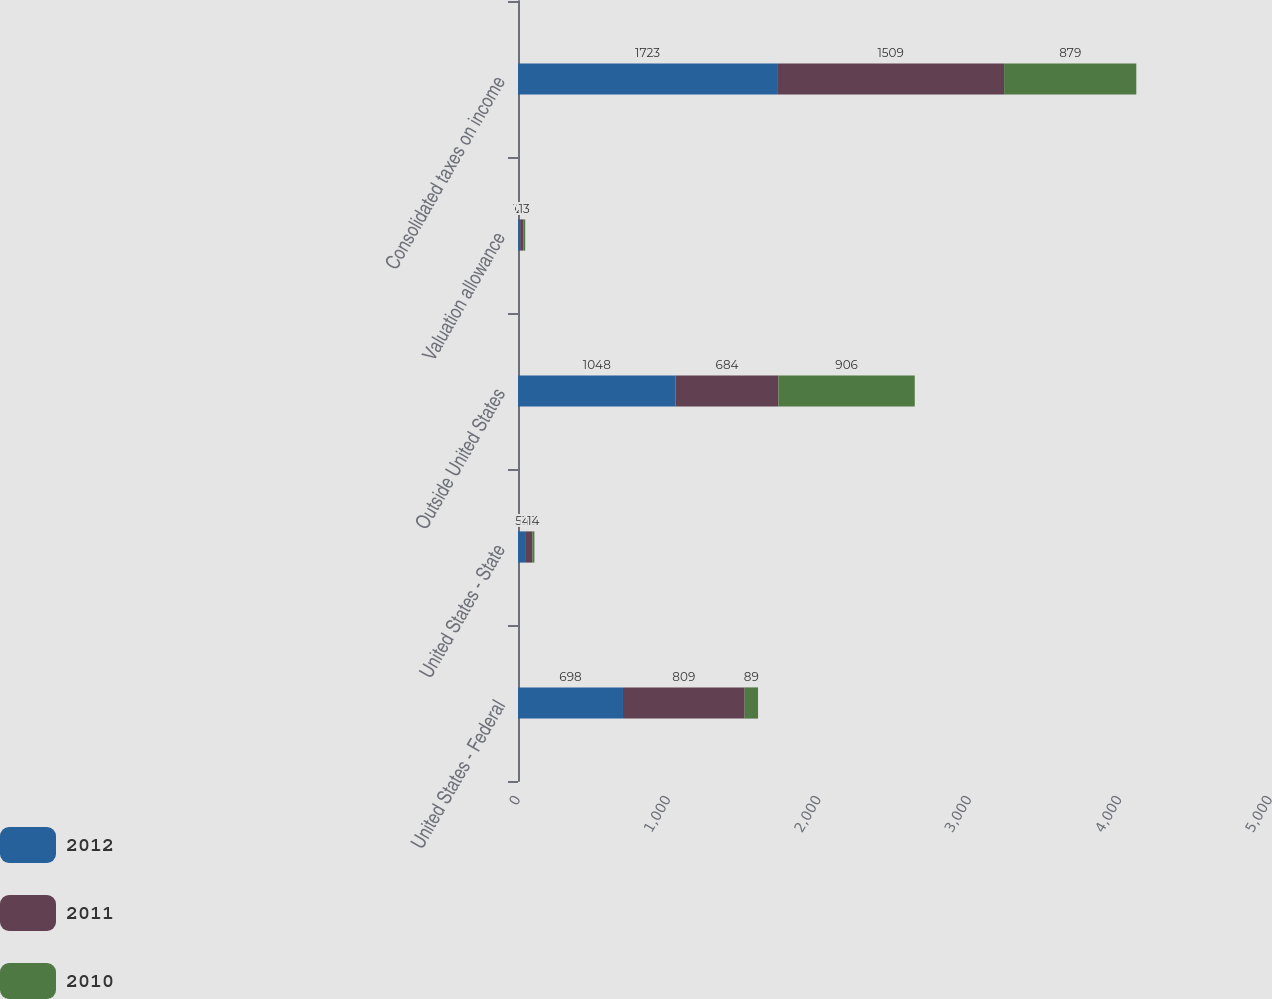Convert chart to OTSL. <chart><loc_0><loc_0><loc_500><loc_500><stacked_bar_chart><ecel><fcel>United States - Federal<fcel>United States - State<fcel>Outside United States<fcel>Valuation allowance<fcel>Consolidated taxes on income<nl><fcel>2012<fcel>698<fcel>53<fcel>1048<fcel>14<fcel>1723<nl><fcel>2011<fcel>809<fcel>42<fcel>684<fcel>21<fcel>1509<nl><fcel>2010<fcel>89<fcel>14<fcel>906<fcel>13<fcel>879<nl></chart> 